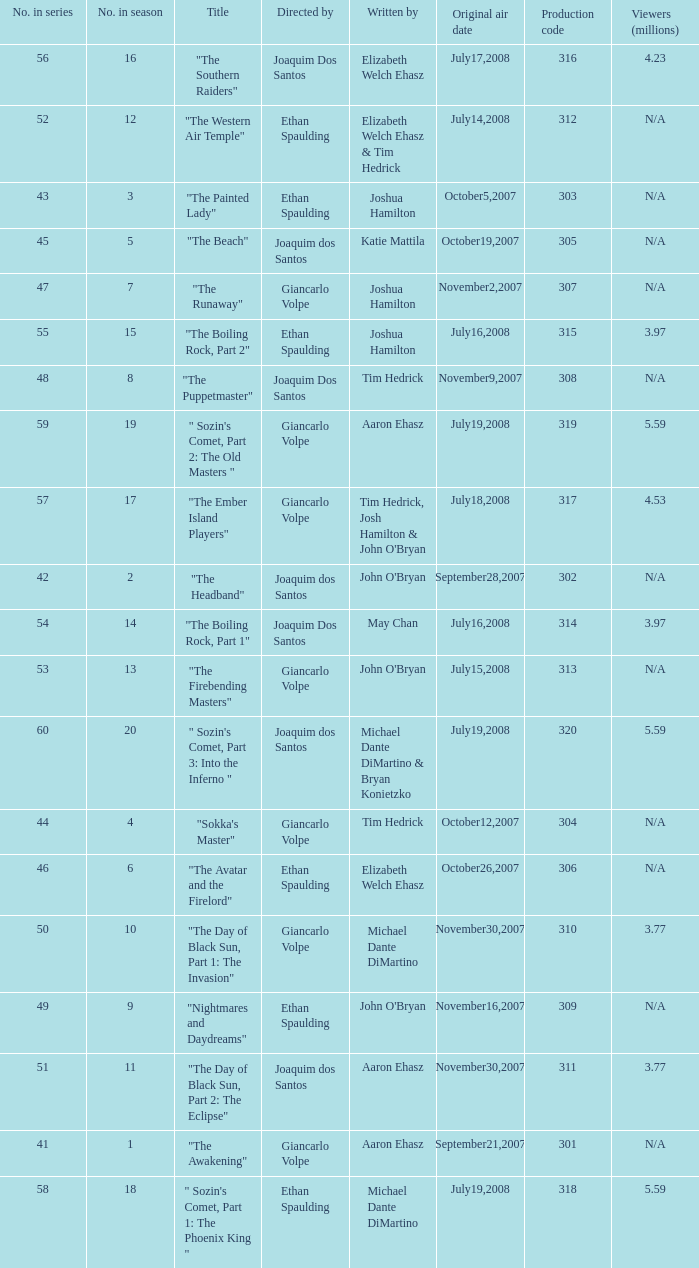What are all the numbers in the series with an episode title of "the beach"? 45.0. Could you help me parse every detail presented in this table? {'header': ['No. in series', 'No. in season', 'Title', 'Directed by', 'Written by', 'Original air date', 'Production code', 'Viewers (millions)'], 'rows': [['56', '16', '"The Southern Raiders"', 'Joaquim Dos Santos', 'Elizabeth Welch Ehasz', 'July17,2008', '316', '4.23'], ['52', '12', '"The Western Air Temple"', 'Ethan Spaulding', 'Elizabeth Welch Ehasz & Tim Hedrick', 'July14,2008', '312', 'N/A'], ['43', '3', '"The Painted Lady"', 'Ethan Spaulding', 'Joshua Hamilton', 'October5,2007', '303', 'N/A'], ['45', '5', '"The Beach"', 'Joaquim dos Santos', 'Katie Mattila', 'October19,2007', '305', 'N/A'], ['47', '7', '"The Runaway"', 'Giancarlo Volpe', 'Joshua Hamilton', 'November2,2007', '307', 'N/A'], ['55', '15', '"The Boiling Rock, Part 2"', 'Ethan Spaulding', 'Joshua Hamilton', 'July16,2008', '315', '3.97'], ['48', '8', '"The Puppetmaster"', 'Joaquim Dos Santos', 'Tim Hedrick', 'November9,2007', '308', 'N/A'], ['59', '19', '" Sozin\'s Comet, Part 2: The Old Masters "', 'Giancarlo Volpe', 'Aaron Ehasz', 'July19,2008', '319', '5.59'], ['57', '17', '"The Ember Island Players"', 'Giancarlo Volpe', "Tim Hedrick, Josh Hamilton & John O'Bryan", 'July18,2008', '317', '4.53'], ['42', '2', '"The Headband"', 'Joaquim dos Santos', "John O'Bryan", 'September28,2007', '302', 'N/A'], ['54', '14', '"The Boiling Rock, Part 1"', 'Joaquim Dos Santos', 'May Chan', 'July16,2008', '314', '3.97'], ['53', '13', '"The Firebending Masters"', 'Giancarlo Volpe', "John O'Bryan", 'July15,2008', '313', 'N/A'], ['60', '20', '" Sozin\'s Comet, Part 3: Into the Inferno "', 'Joaquim dos Santos', 'Michael Dante DiMartino & Bryan Konietzko', 'July19,2008', '320', '5.59'], ['44', '4', '"Sokka\'s Master"', 'Giancarlo Volpe', 'Tim Hedrick', 'October12,2007', '304', 'N/A'], ['46', '6', '"The Avatar and the Firelord"', 'Ethan Spaulding', 'Elizabeth Welch Ehasz', 'October26,2007', '306', 'N/A'], ['50', '10', '"The Day of Black Sun, Part 1: The Invasion"', 'Giancarlo Volpe', 'Michael Dante DiMartino', 'November30,2007', '310', '3.77'], ['49', '9', '"Nightmares and Daydreams"', 'Ethan Spaulding', "John O'Bryan", 'November16,2007', '309', 'N/A'], ['51', '11', '"The Day of Black Sun, Part 2: The Eclipse"', 'Joaquim dos Santos', 'Aaron Ehasz', 'November30,2007', '311', '3.77'], ['41', '1', '"The Awakening"', 'Giancarlo Volpe', 'Aaron Ehasz', 'September21,2007', '301', 'N/A'], ['58', '18', '" Sozin\'s Comet, Part 1: The Phoenix King "', 'Ethan Spaulding', 'Michael Dante DiMartino', 'July19,2008', '318', '5.59']]} 